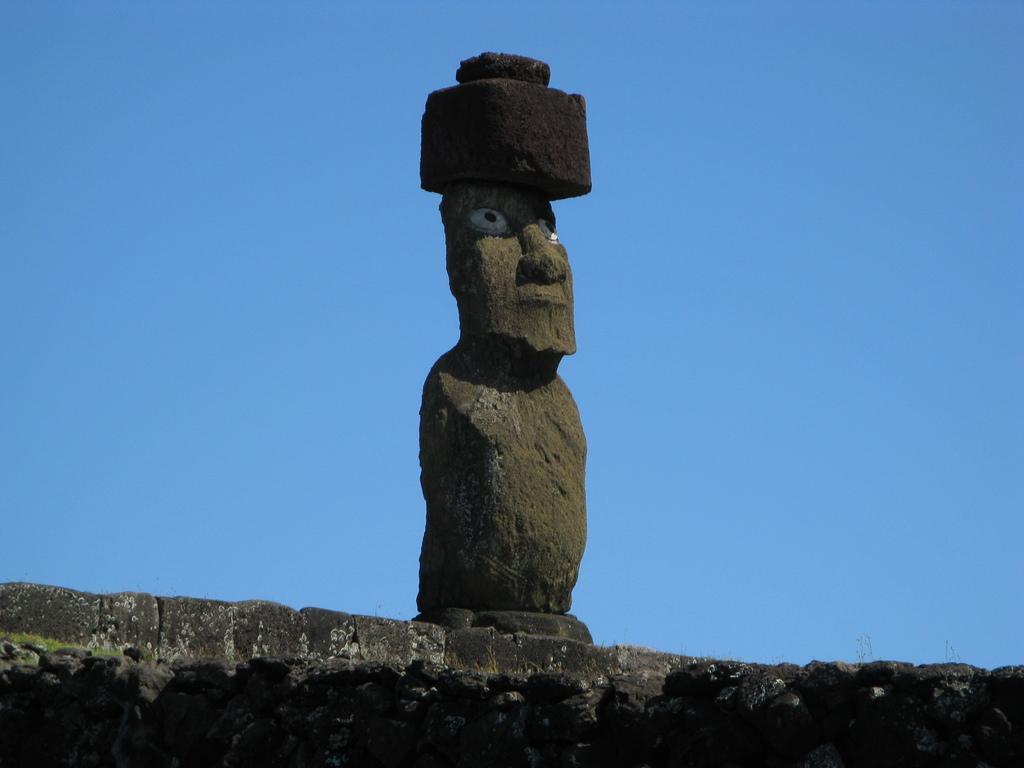Please provide a concise description of this image. In the background portion of the picture we can see a clear blue sky. At the bottom portion of the picture we can see the wall and on the wall we can see a sculpture. 